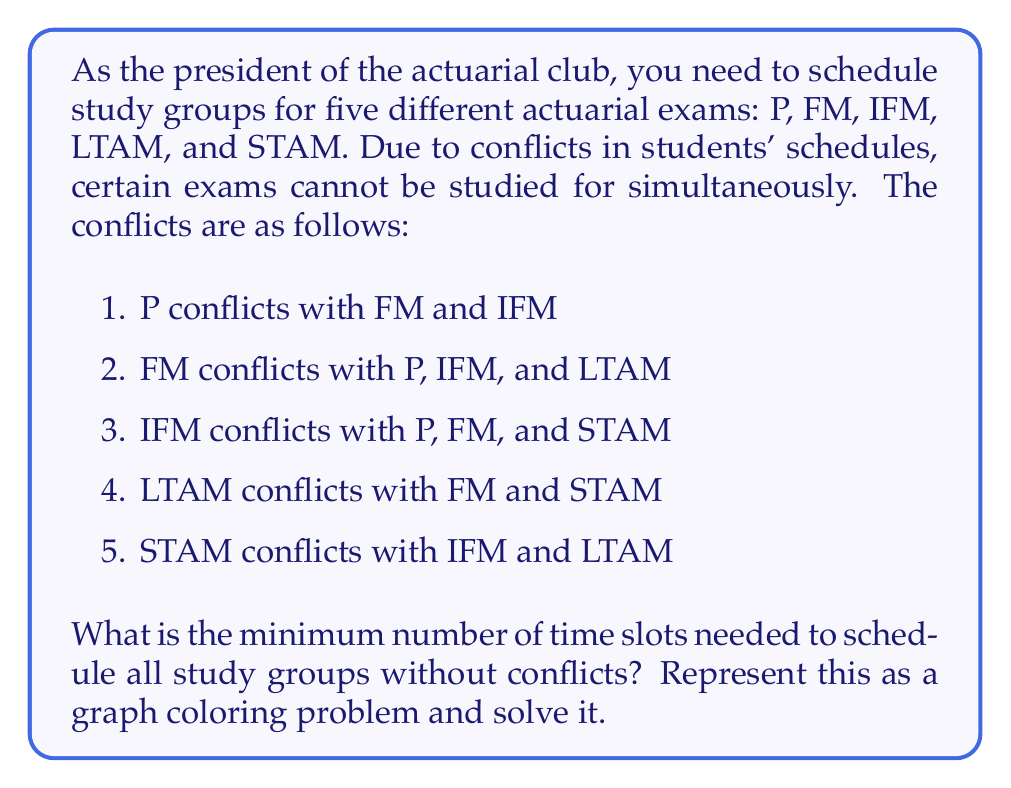Could you help me with this problem? To solve this problem using graph theory, we can follow these steps:

1. Create a graph where each vertex represents an exam, and edges connect exams that conflict with each other.

2. The graph can be represented as follows:

[asy]
unitsize(1cm);
pair A = (0,0), B = (2,0), C = (1,1.7), D = (-1,1), E = (3,1);
draw(A--B--C--A--D--B);
draw(C--E--D);
draw(A--C);
label("P", A, SW);
label("FM", B, SE);
label("IFM", C, N);
label("LTAM", D, NW);
label("STAM", E, NE);
[/asy]

3. The graph coloring problem asks to assign colors to vertices such that no two adjacent vertices have the same color. Each color represents a time slot.

4. We can solve this using the greedy coloring algorithm:
   a. Order the vertices by degree (number of edges) in descending order.
   b. Assign the first available color to each vertex that doesn't conflict with its neighbors.

5. Ordering the vertices by degree:
   FM (4 edges), IFM (4 edges), P (3 edges), LTAM (3 edges), STAM (2 edges)

6. Coloring process:
   - FM: Assign Color 1
   - IFM: Assign Color 2 (conflicts with FM)
   - P: Assign Color 3 (conflicts with FM and IFM)
   - LTAM: Assign Color 2 (conflicts with FM, but not IFM)
   - STAM: Assign Color 1 (conflicts with IFM and LTAM, but not FM)

7. The coloring uses 3 colors, which means we need a minimum of 3 time slots.
Answer: The minimum number of time slots needed to schedule all study groups without conflicts is 3. 